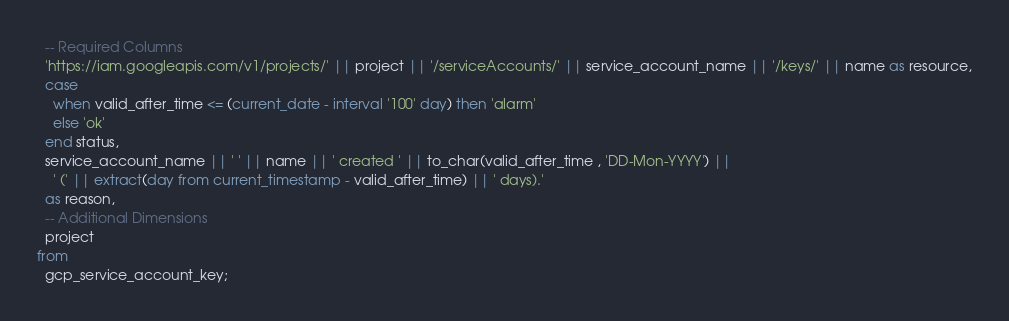Convert code to text. <code><loc_0><loc_0><loc_500><loc_500><_SQL_>  -- Required Columns
  'https://iam.googleapis.com/v1/projects/' || project || '/serviceAccounts/' || service_account_name || '/keys/' || name as resource,
  case
    when valid_after_time <= (current_date - interval '100' day) then 'alarm'
    else 'ok'
  end status,
  service_account_name || ' ' || name || ' created ' || to_char(valid_after_time , 'DD-Mon-YYYY') ||
    ' (' || extract(day from current_timestamp - valid_after_time) || ' days).'
  as reason,
  -- Additional Dimensions
  project
from
  gcp_service_account_key;</code> 